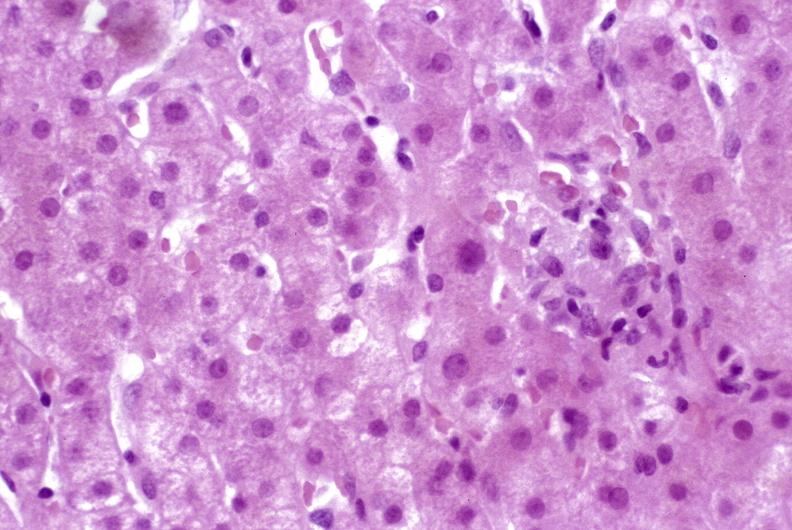s yellow color present?
Answer the question using a single word or phrase. No 